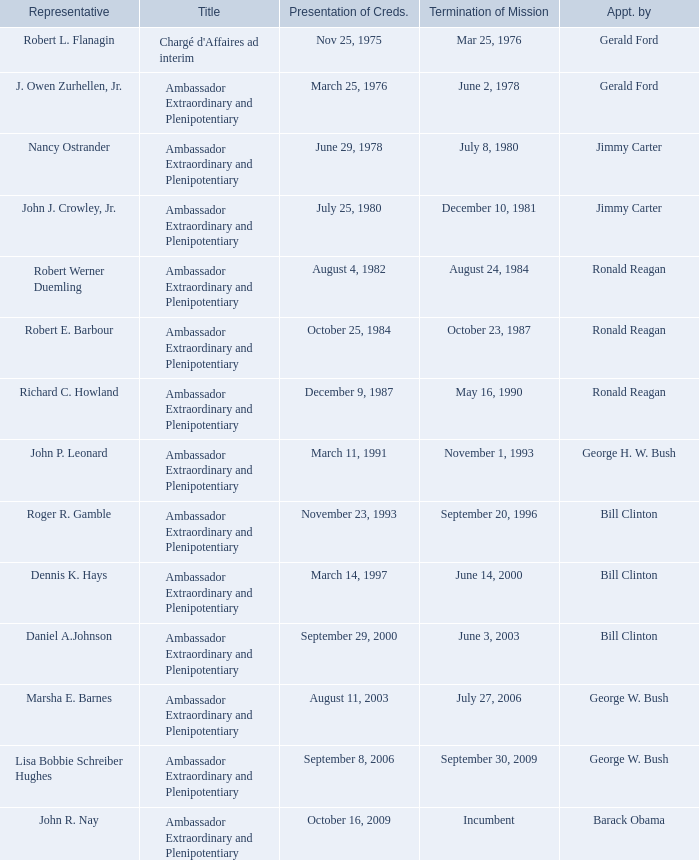Which representative has a Termination of MIssion date Mar 25, 1976? Robert L. Flanagin. 